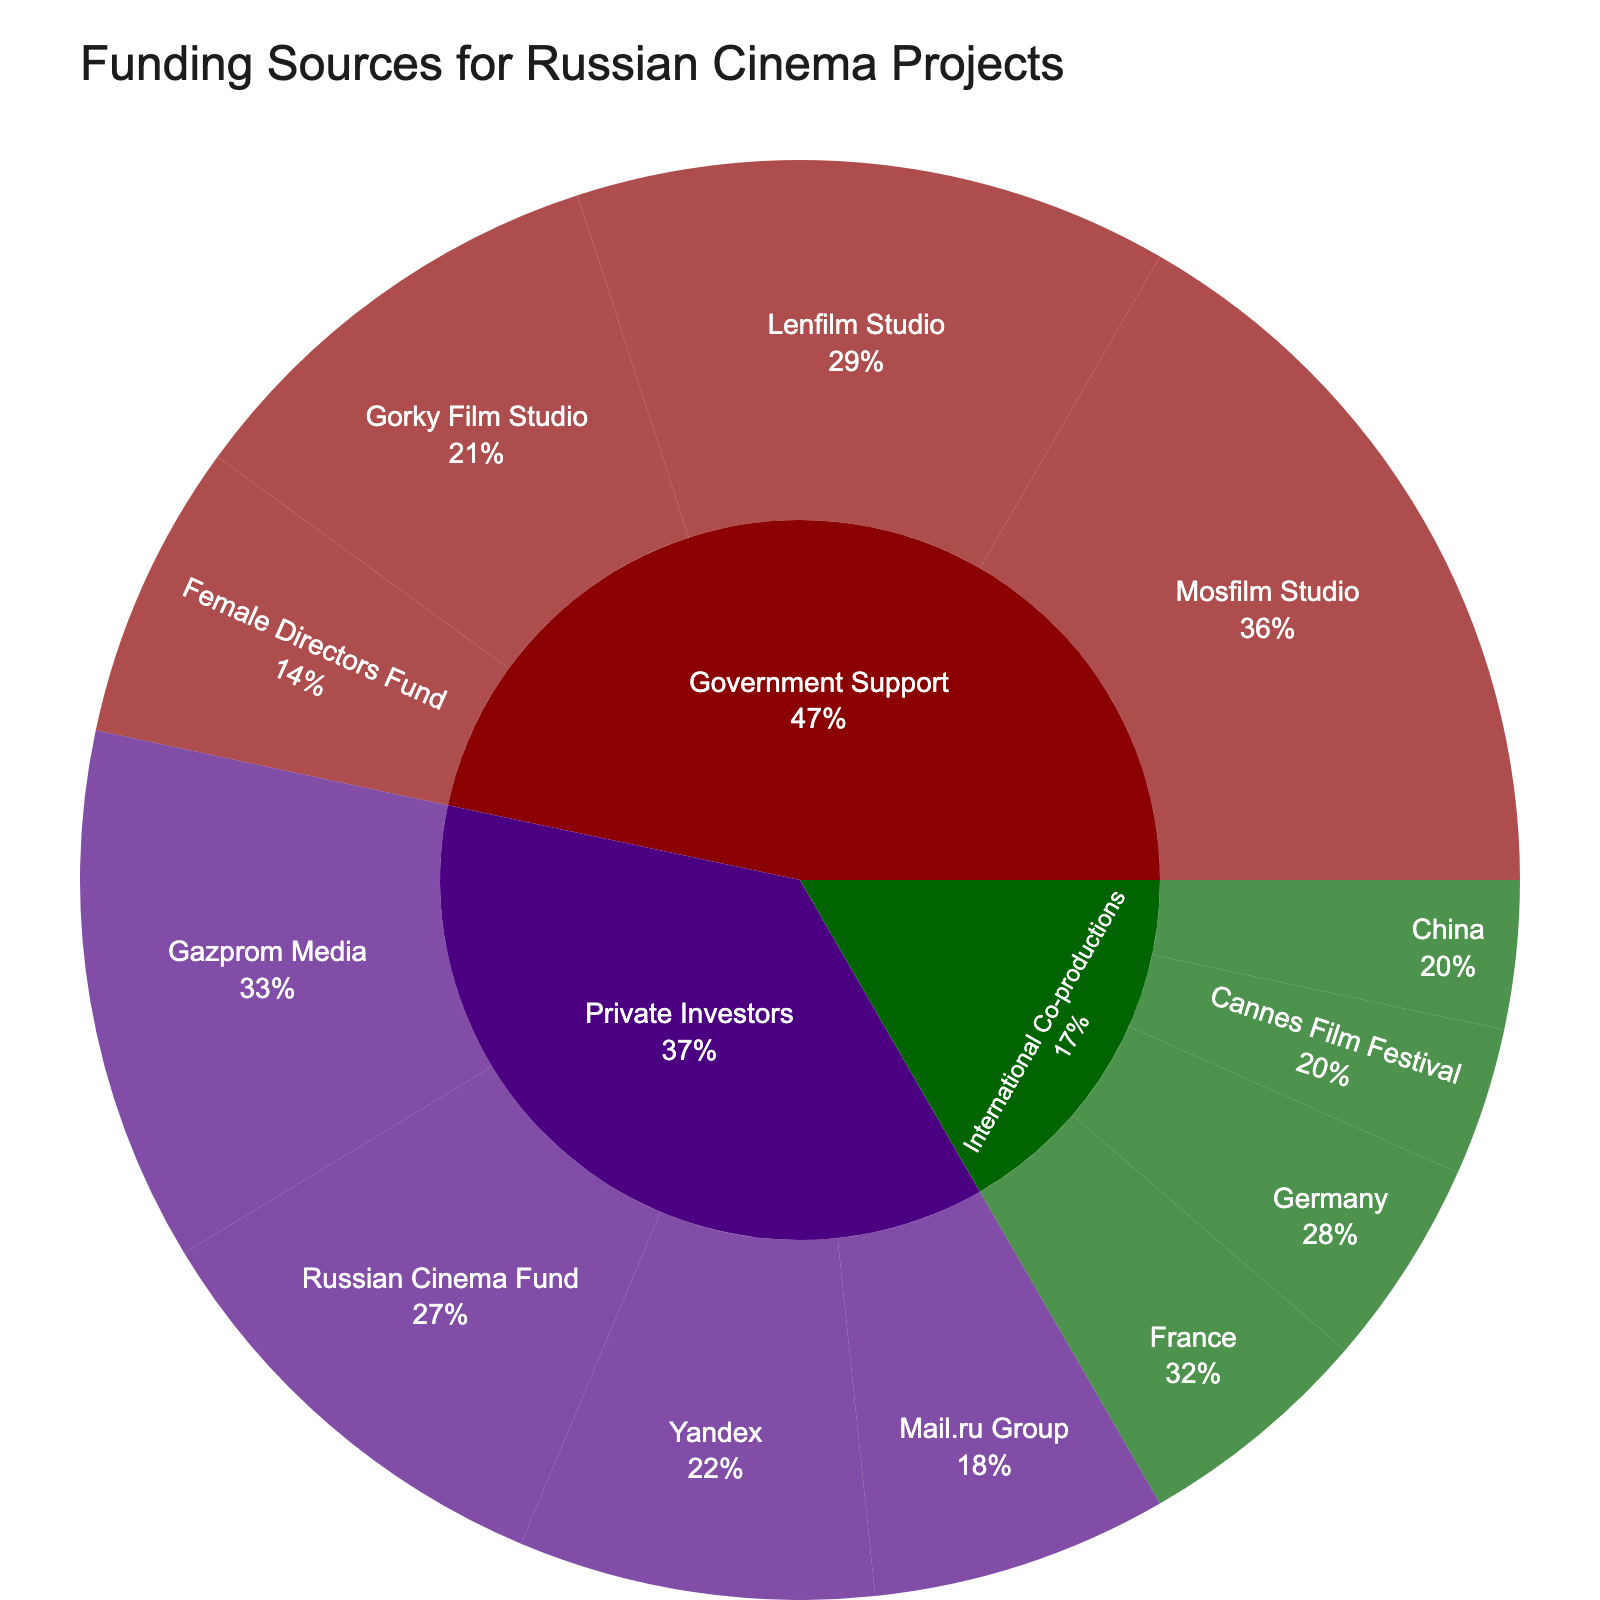What is the title of the plot? The title of the plot is displayed at the top center of the figure. It provides context for the data being visualized.
Answer: Funding Sources for Russian Cinema Projects Which funding source has the largest portion of the total funding? To determine this, look for the segment in the sunburst plot that spans the largest area compared to others.
Answer: Government Support What percentage of the total funding does Mosfilm Studio receive from government support? Mosfilm Studio is under the "Government Support" category. The plot should show the percentage next to the label Mosfilm Studio.
Answer: 41.7% What is the combined funding amount received from Lenfilm Studio and Gorky Film Studio? Add the values of Lenfilm Studio (20) and Gorky Film Studio (15) to get the total funding combined from these studios.
Answer: 35 How does the funding from Private Investors for Gazprom Media compare to Mail.ru Group? Compare the values for Gazprom Media (18) and Mail.ru Group (10). Generally, subtract the smaller value from the larger one.
Answer: Gazprom Media receives 8 more than Mail.ru Group What fraction of the total Private Investors category funding is received by the Russian Cinema Fund? Sum up all contributions under Private Investors and find the fraction contributed by the Russian Cinema Fund (15). The total is 18 + 12 + 10 + 15 = 55.
Answer: 15/55 or approximately 27.3% Which international co-production partner provides the least funding? Look at the "International Co-productions" section and find the partner with the smallest value.
Answer: China What is the total funding from international co-productions? Add up all the values under the "International Co-productions" category. The values are 8 (France), 7 (Germany), 5 (China), and 5 (Cannes Film Festival).
Answer: 25 How does the funding from the Female Directors Fund compare to the combined funding from Yandex and Mail.ru Group? First, find the value for Female Directors Fund (10), then sum the values for Yandex (12) and Mail.ru Group (10), and compare.
Answer: The combined funding from Yandex and Mail.ru Group is 22, which is 12 more than the Female Directors Fund What percentage of the total funding does the "Government Support" category represent? Sum up all values within the "Government Support" category and divide by the overall total funding. Total funding is 25 + 20 + 15 + 10 = 70 under Government Support.
Answer: Around 46.4% (70/151) 